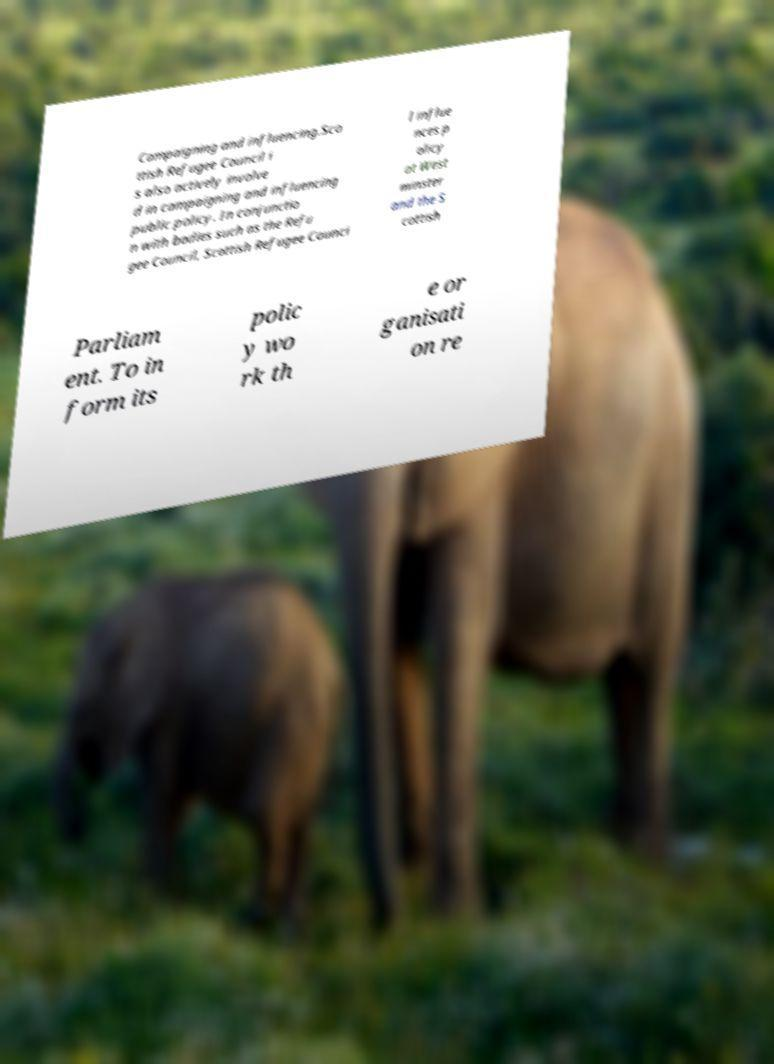What messages or text are displayed in this image? I need them in a readable, typed format. Campaigning and influencing.Sco ttish Refugee Council i s also actively involve d in campaigning and influencing public policy. In conjunctio n with bodies such as the Refu gee Council, Scottish Refugee Counci l influe nces p olicy at West minster and the S cottish Parliam ent. To in form its polic y wo rk th e or ganisati on re 